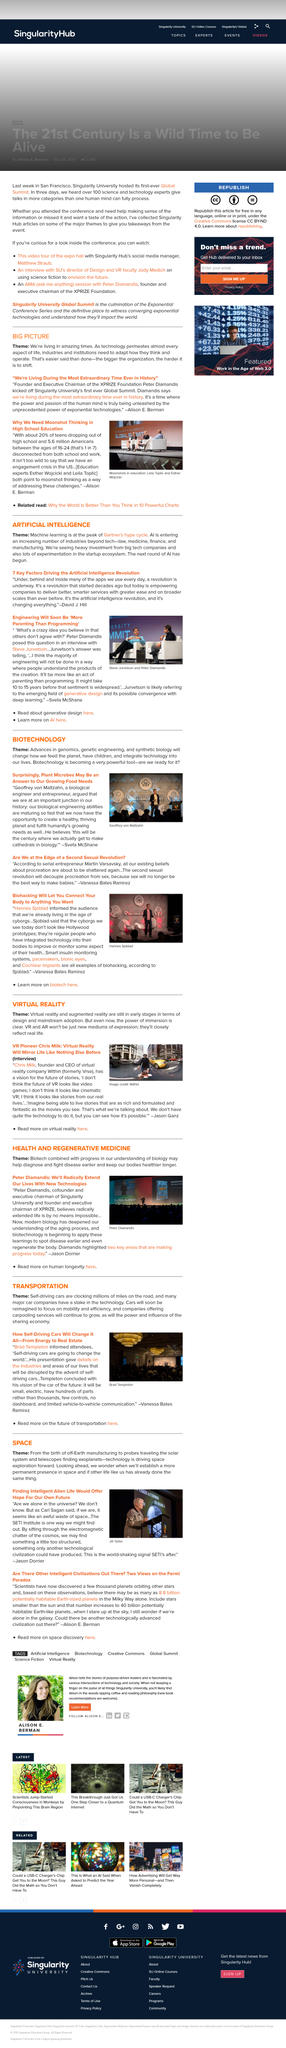Give some essential details in this illustration. The larger the organization, the more challenging it becomes to effect change. Peter Diamandis had an interview with Steve Jurvetson. The SETI Institute was said to sift through electromagnetic signals in search of extraterrestrial life. The person depicted in the image is Jill Tarter. Sjoblad informed the audience that we are already living in the age of cyborgs, as we are all using various technological devices and interfaces on a daily basis. 